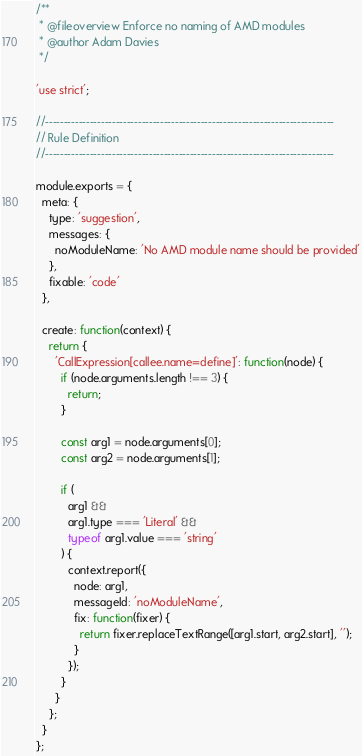Convert code to text. <code><loc_0><loc_0><loc_500><loc_500><_JavaScript_>/**
 * @fileoverview Enforce no naming of AMD modules
 * @author Adam Davies
 */

'use strict';

//------------------------------------------------------------------------------
// Rule Definition
//------------------------------------------------------------------------------

module.exports = {
  meta: {
    type: 'suggestion',
    messages: {
      noModuleName: 'No AMD module name should be provided'
    },
    fixable: 'code'
  },

  create: function(context) {
    return {
      'CallExpression[callee.name=define]': function(node) {
        if (node.arguments.length !== 3) {
          return;
        }

        const arg1 = node.arguments[0];
        const arg2 = node.arguments[1];

        if (
          arg1 &&
          arg1.type === 'Literal' &&
          typeof arg1.value === 'string'
        ) {
          context.report({
            node: arg1,
            messageId: 'noModuleName',
            fix: function(fixer) {
              return fixer.replaceTextRange([arg1.start, arg2.start], '');
            }
          });
        }
      }
    };
  }
};</code> 